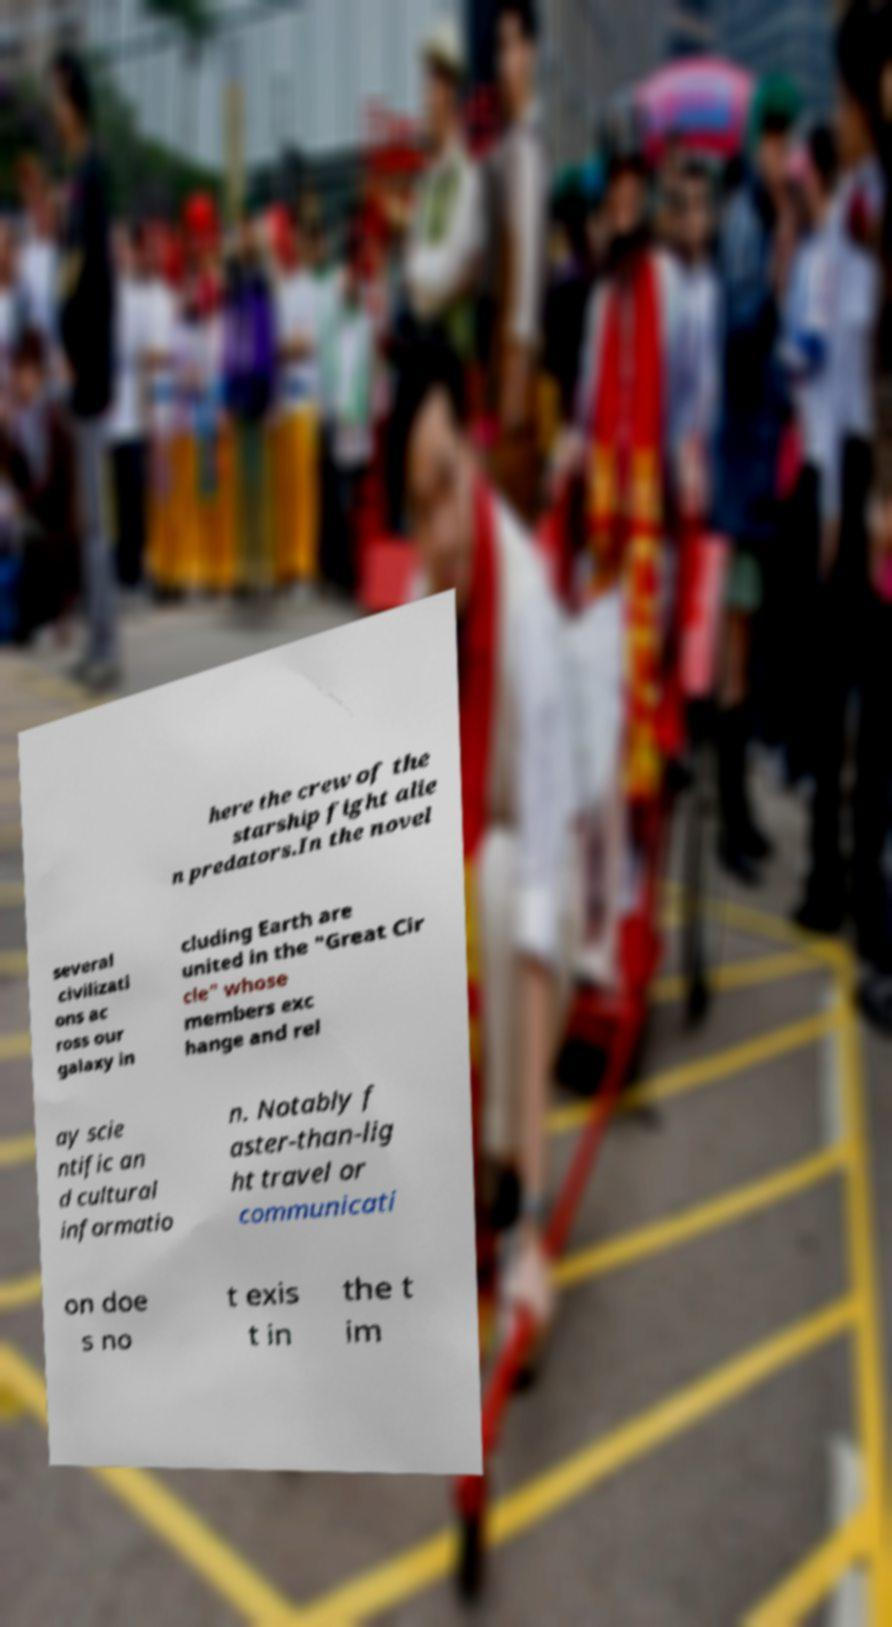Can you read and provide the text displayed in the image?This photo seems to have some interesting text. Can you extract and type it out for me? here the crew of the starship fight alie n predators.In the novel several civilizati ons ac ross our galaxy in cluding Earth are united in the "Great Cir cle" whose members exc hange and rel ay scie ntific an d cultural informatio n. Notably f aster-than-lig ht travel or communicati on doe s no t exis t in the t im 